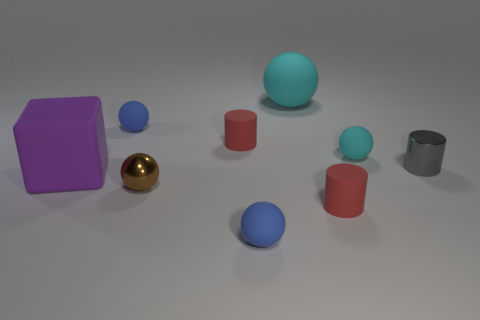Subtract all brown balls. How many balls are left? 4 Subtract all small metallic spheres. How many spheres are left? 4 Subtract all purple balls. Subtract all cyan cylinders. How many balls are left? 5 Add 1 small spheres. How many objects exist? 10 Subtract all spheres. How many objects are left? 4 Subtract all big metal cylinders. Subtract all gray cylinders. How many objects are left? 8 Add 6 tiny cylinders. How many tiny cylinders are left? 9 Add 2 tiny brown metallic objects. How many tiny brown metallic objects exist? 3 Subtract 2 blue balls. How many objects are left? 7 